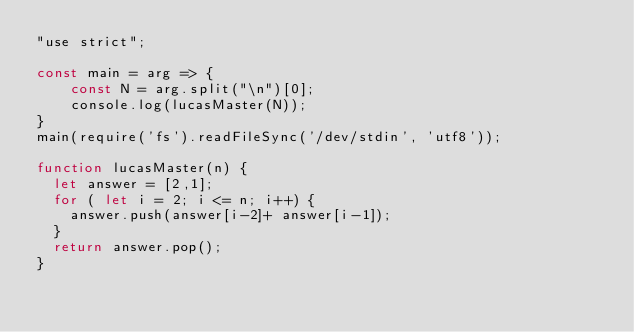Convert code to text. <code><loc_0><loc_0><loc_500><loc_500><_JavaScript_>"use strict";
    
const main = arg => {
    const N = arg.split("\n")[0];
    console.log(lucasMaster(N));
}
main(require('fs').readFileSync('/dev/stdin', 'utf8'));

function lucasMaster(n) {
  let answer = [2,1];
  for ( let i = 2; i <= n; i++) {
    answer.push(answer[i-2]+ answer[i-1]);
  }
  return answer.pop();
}</code> 